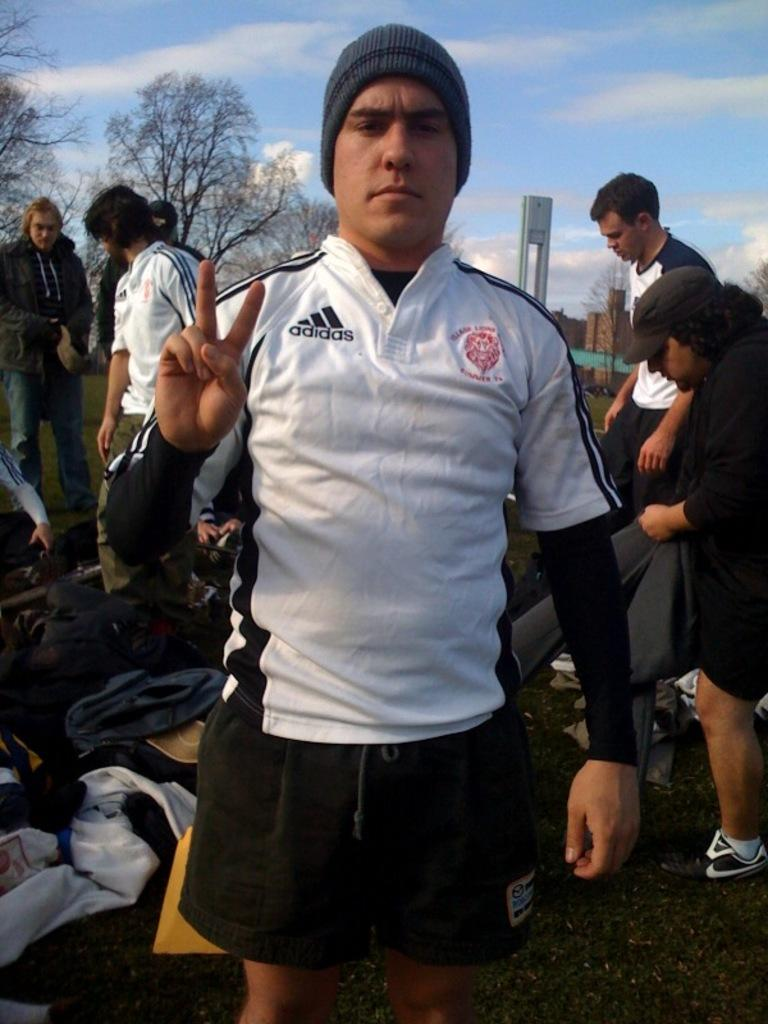Provide a one-sentence caption for the provided image. A man wearing a white Adidas shirt ready to go on a trip. 